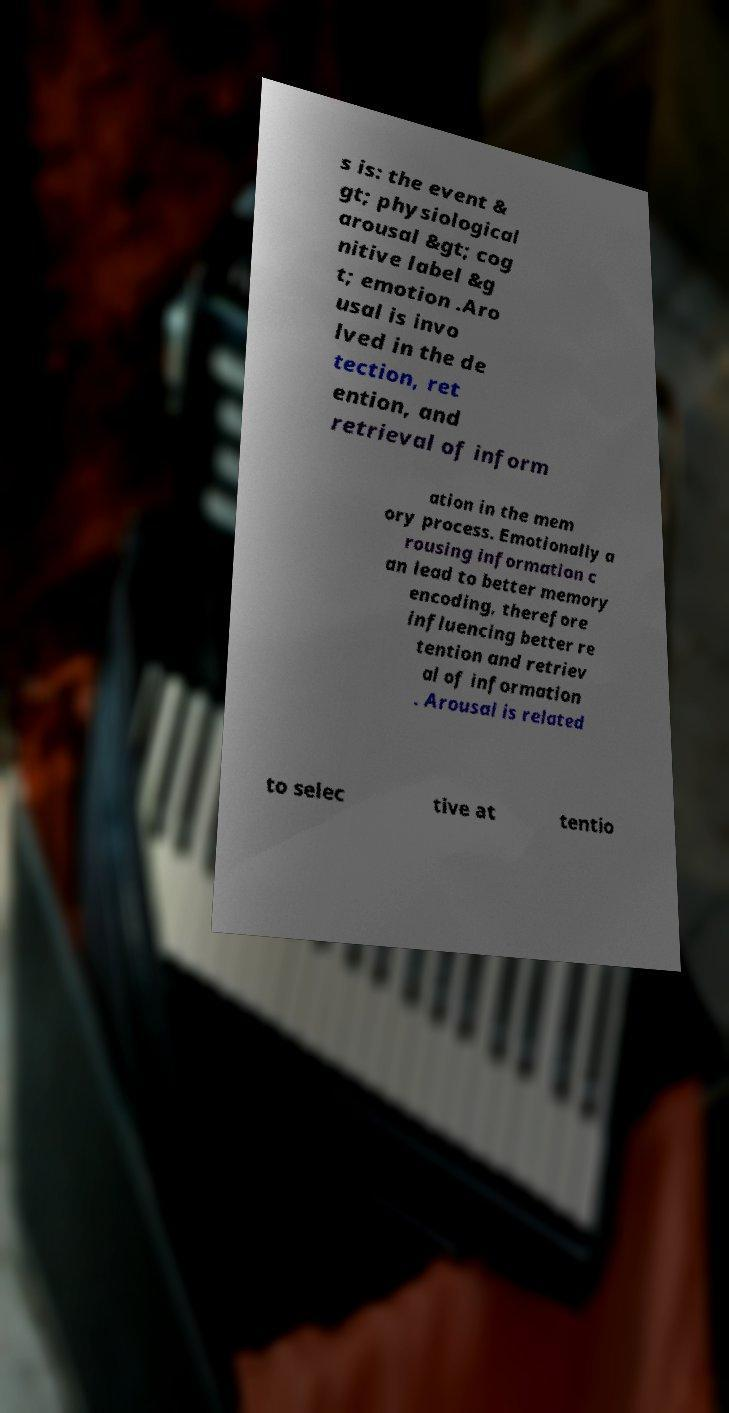I need the written content from this picture converted into text. Can you do that? s is: the event & gt; physiological arousal &gt; cog nitive label &g t; emotion .Aro usal is invo lved in the de tection, ret ention, and retrieval of inform ation in the mem ory process. Emotionally a rousing information c an lead to better memory encoding, therefore influencing better re tention and retriev al of information . Arousal is related to selec tive at tentio 